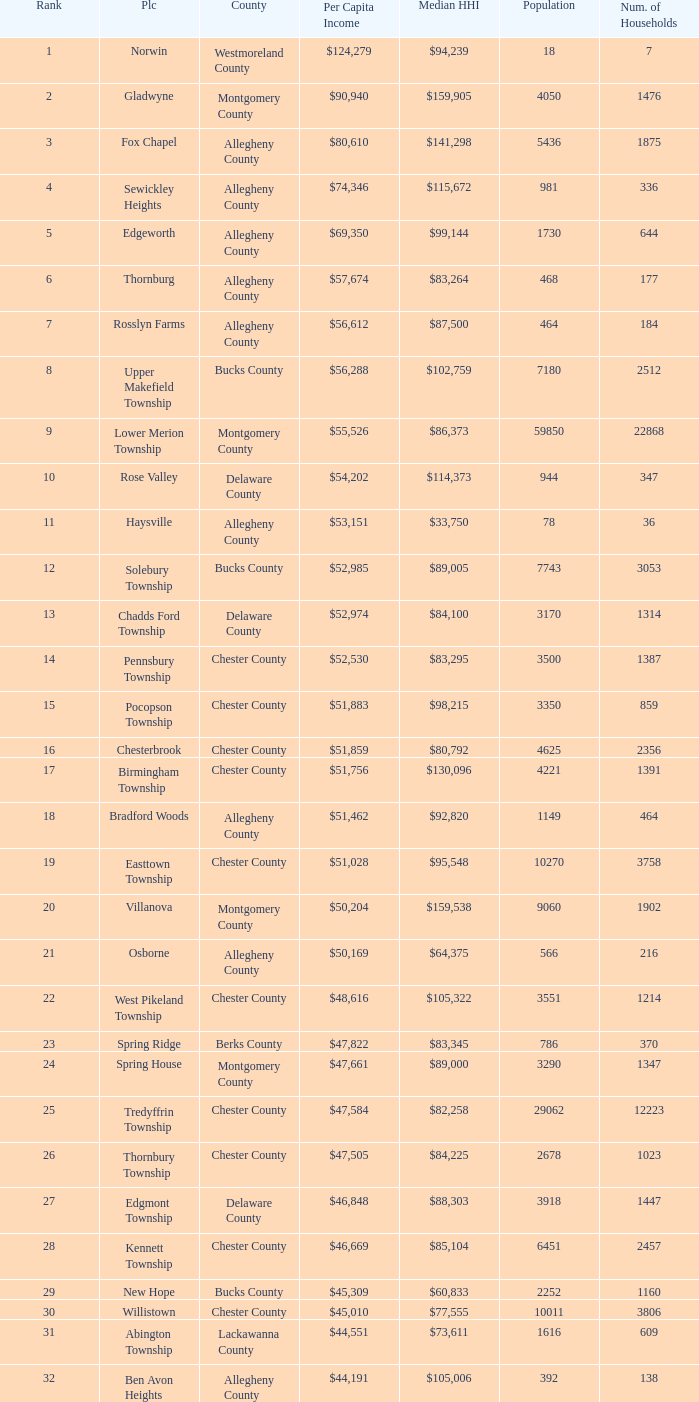What is the per capita income for Fayette County? $42,131. 